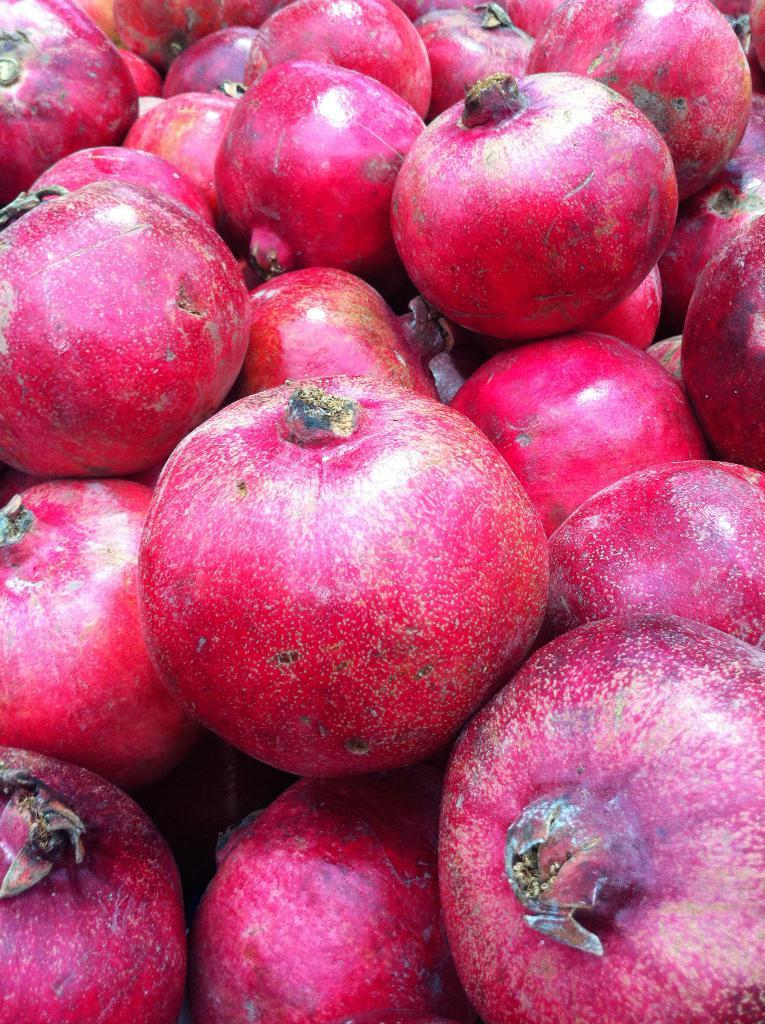What type of fruit is present in the image? There are pomegranates in the image. Can you describe the appearance of the pomegranates? The pomegranates have a red skin and are filled with small, juicy seeds. How many pomegranates are visible in the image? The number of pomegranates cannot be determined from the image alone. What type of tooth is visible in the image? There are no teeth present in the image; it features pomegranates. How many layers of cake can be seen in the image? There are no cakes present in the image; it features pomegranates. 